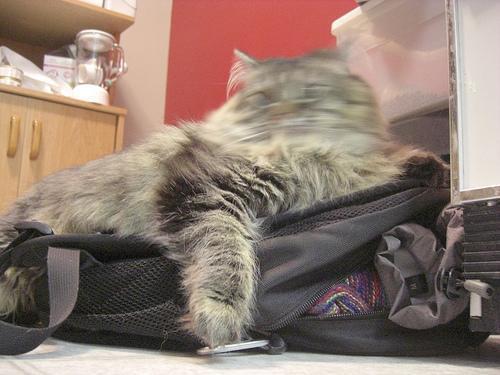How many cats are shown?
Give a very brief answer. 1. 